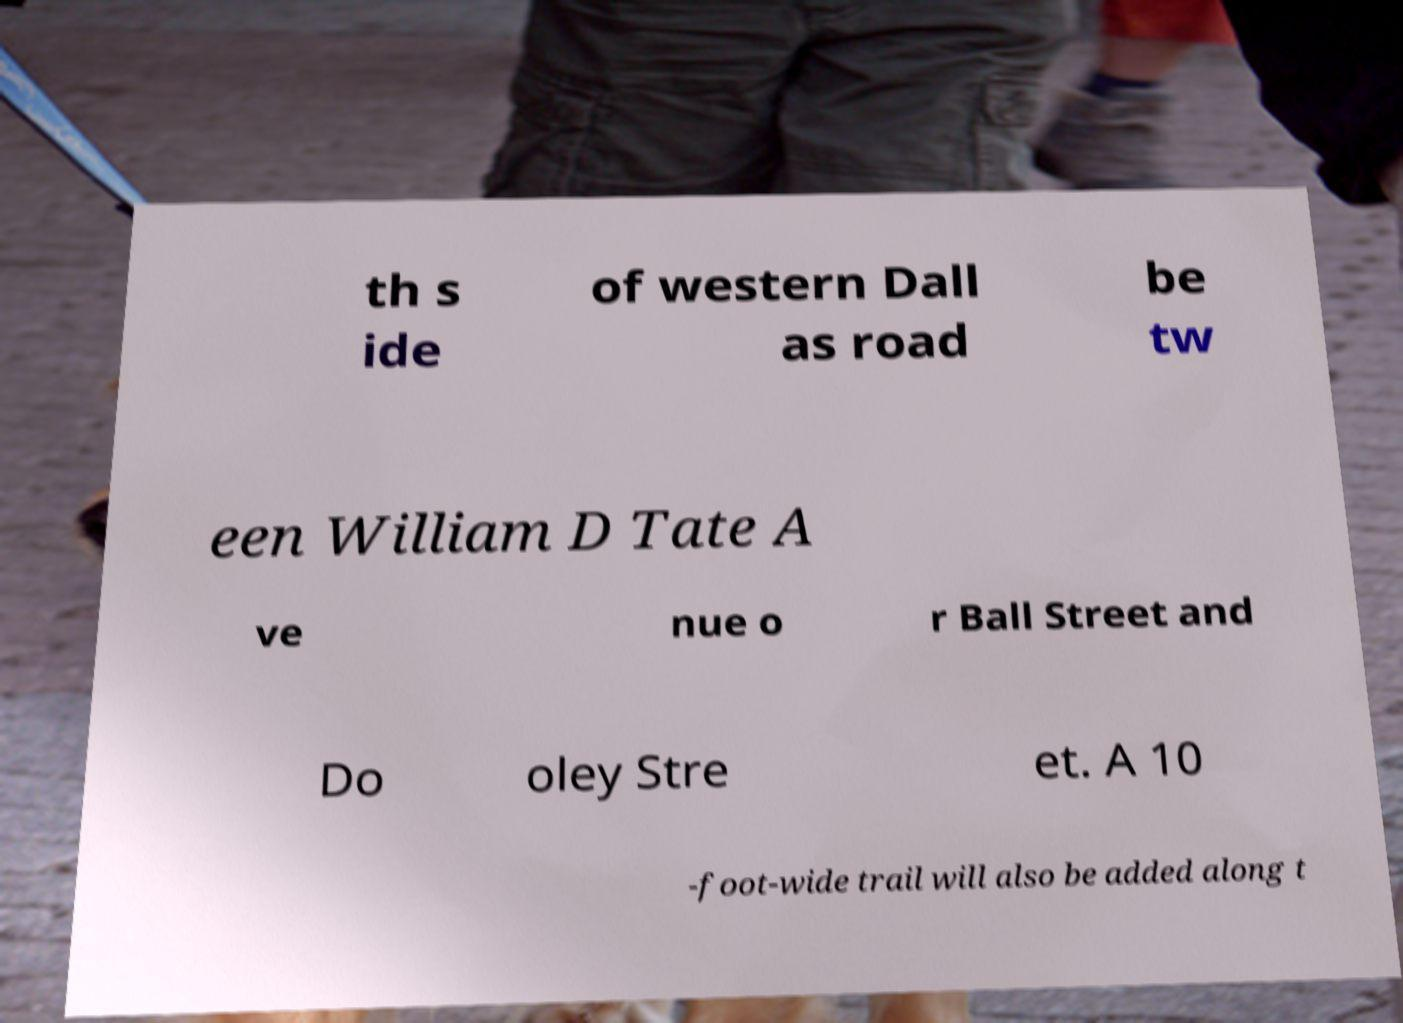Please read and relay the text visible in this image. What does it say? th s ide of western Dall as road be tw een William D Tate A ve nue o r Ball Street and Do oley Stre et. A 10 -foot-wide trail will also be added along t 